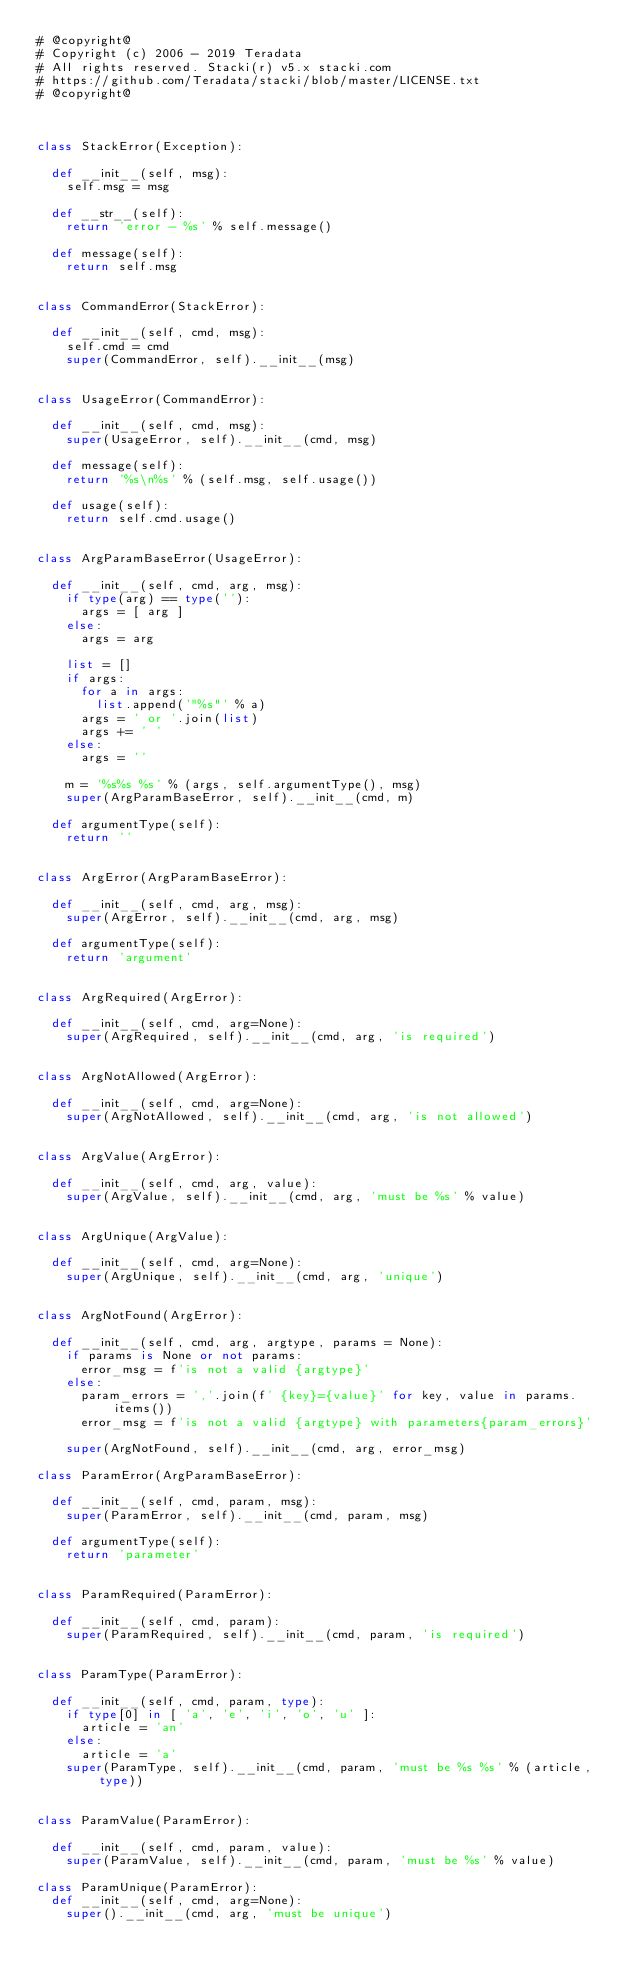<code> <loc_0><loc_0><loc_500><loc_500><_Python_># @copyright@
# Copyright (c) 2006 - 2019 Teradata
# All rights reserved. Stacki(r) v5.x stacki.com
# https://github.com/Teradata/stacki/blob/master/LICENSE.txt
# @copyright@



class StackError(Exception):

	def __init__(self, msg):
		self.msg = msg

	def __str__(self):
		return 'error - %s' % self.message()

	def message(self):
		return self.msg
	

class CommandError(StackError):

	def __init__(self, cmd, msg):
		self.cmd = cmd
		super(CommandError, self).__init__(msg)


class UsageError(CommandError):
	
	def __init__(self, cmd, msg):
		super(UsageError, self).__init__(cmd, msg)

	def message(self):
		return '%s\n%s' % (self.msg, self.usage())

	def usage(self):
		return self.cmd.usage()


class ArgParamBaseError(UsageError):
	
	def __init__(self, cmd, arg, msg):
		if type(arg) == type(''):
			args = [ arg ]
		else:
			args = arg
			
		list = []
		if args:
			for a in args:
				list.append('"%s"' % a)
			args = ' or '.join(list)
			args += ' '
		else:
			args = ''
				
		m = '%s%s %s' % (args, self.argumentType(), msg)
		super(ArgParamBaseError, self).__init__(cmd, m)

	def argumentType(self):
		return ''
	

class ArgError(ArgParamBaseError):
	
	def __init__(self, cmd, arg, msg):
		super(ArgError, self).__init__(cmd, arg, msg)

	def argumentType(self):
		return 'argument'

		
class ArgRequired(ArgError):

	def __init__(self, cmd, arg=None):
		super(ArgRequired, self).__init__(cmd, arg, 'is required')


class ArgNotAllowed(ArgError):

	def __init__(self, cmd, arg=None):
		super(ArgNotAllowed, self).__init__(cmd, arg, 'is not allowed')


class ArgValue(ArgError):

	def __init__(self, cmd, arg, value):
		super(ArgValue, self).__init__(cmd, arg, 'must be %s' % value)


class ArgUnique(ArgValue):

	def __init__(self, cmd, arg=None):
		super(ArgUnique, self).__init__(cmd, arg, 'unique')


class ArgNotFound(ArgError):

	def __init__(self, cmd, arg, argtype, params = None):
		if params is None or not params:
			error_msg = f'is not a valid {argtype}'
		else:			
			param_errors = ','.join(f' {key}={value}' for key, value in params.items())
			error_msg = f'is not a valid {argtype} with parameters{param_errors}'

		super(ArgNotFound, self).__init__(cmd, arg, error_msg)

class ParamError(ArgParamBaseError):
	
	def __init__(self, cmd, param, msg):
		super(ParamError, self).__init__(cmd, param, msg)

	def argumentType(self):
		return 'parameter'
		

class ParamRequired(ParamError):

	def __init__(self, cmd, param):
		super(ParamRequired, self).__init__(cmd, param, 'is required')


class ParamType(ParamError):

	def __init__(self, cmd, param, type):
		if type[0] in [ 'a', 'e', 'i', 'o', 'u' ]:
			article = 'an'
		else:
			article = 'a'
		super(ParamType, self).__init__(cmd, param, 'must be %s %s' % (article, type))


class ParamValue(ParamError):

	def __init__(self, cmd, param, value):
		super(ParamValue, self).__init__(cmd, param, 'must be %s' % value)

class ParamUnique(ParamError):
	def __init__(self, cmd, arg=None):
		super().__init__(cmd, arg, 'must be unique')
</code> 